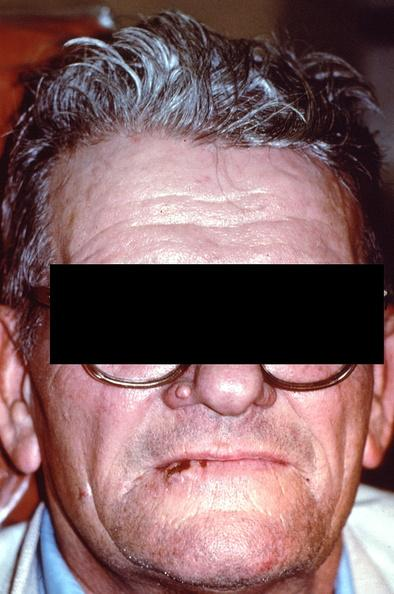what is present?
Answer the question using a single word or phrase. Gastrointestinal 